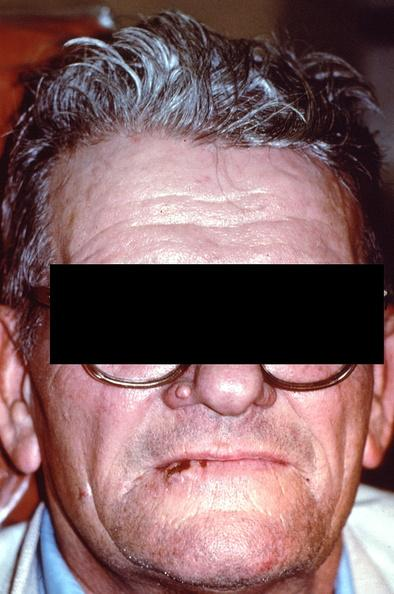what is present?
Answer the question using a single word or phrase. Gastrointestinal 